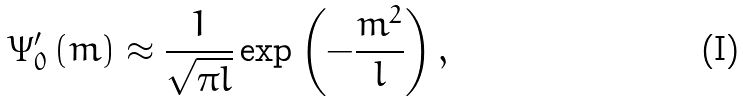<formula> <loc_0><loc_0><loc_500><loc_500>\Psi ^ { \prime } _ { 0 } \left ( m \right ) \approx \frac { 1 } { \sqrt { \pi l } } \exp \left ( - \frac { m ^ { 2 } } { l } \right ) ,</formula> 